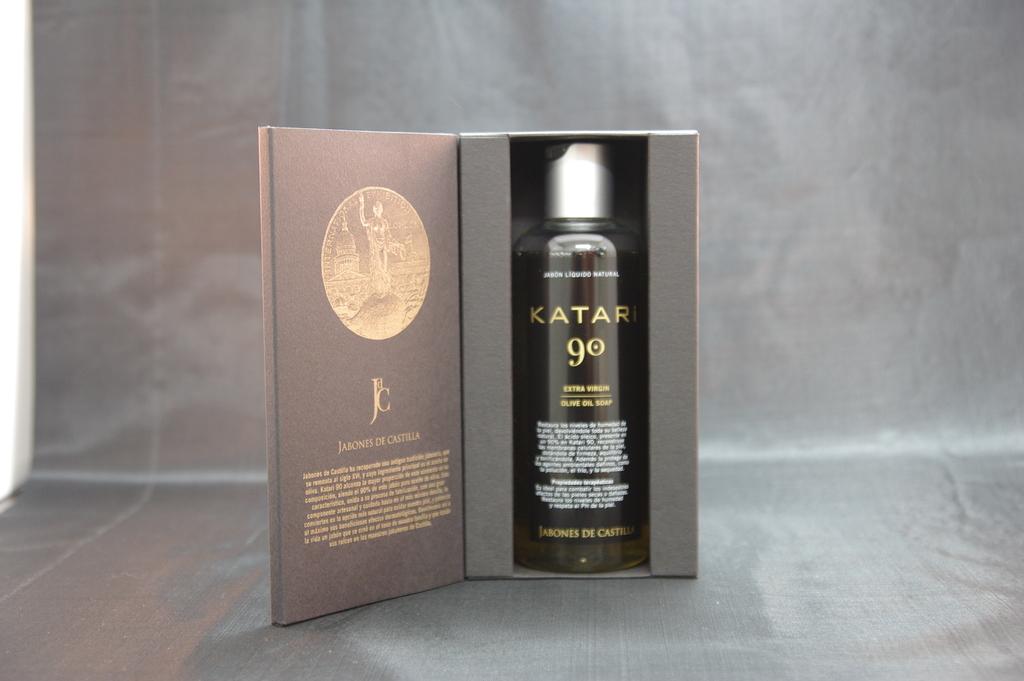What is the product in the bottle?
Keep it short and to the point. Katari. 